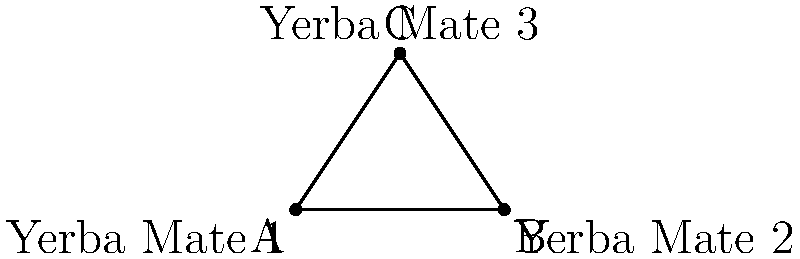In a traditional Paraguayan ceremony, three yerba mate gourds are arranged in a triangular formation. The angle between two gourds is a right angle (90°), and another angle is 30°. What is the measure of the third angle, represented by $x°$ in the diagram? To solve this problem, let's follow these steps:

1) In any triangle, the sum of all interior angles is always 180°.

2) We are given that one angle is a right angle (90°) and another is 30°.

3) Let's call the unknown angle $x°$.

4) We can set up an equation based on the fact that all angles in a triangle sum to 180°:

   $90° + 30° + x° = 180°$

5) Simplify the left side of the equation:

   $120° + x° = 180°$

6) Subtract 120° from both sides:

   $x° = 180° - 120°$

7) Simplify:

   $x° = 60°$

Therefore, the measure of the third angle in the triangular arrangement of yerba mate gourds is 60°.
Answer: $60°$ 